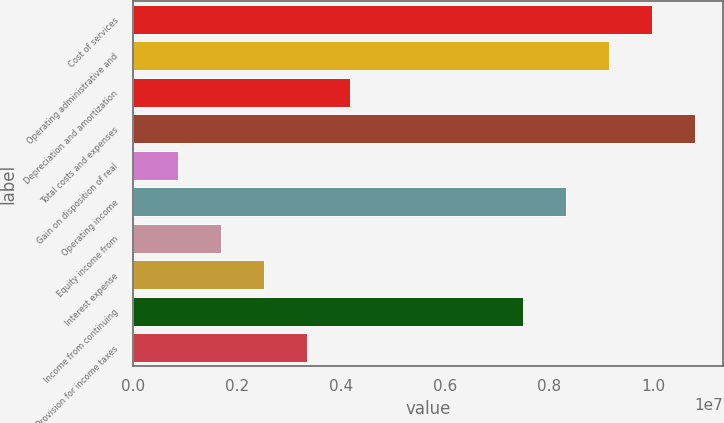Convert chart. <chart><loc_0><loc_0><loc_500><loc_500><bar_chart><fcel>Cost of services<fcel>Operating administrative and<fcel>Depreciation and amortization<fcel>Total costs and expenses<fcel>Gain on disposition of real<fcel>Operating income<fcel>Equity income from<fcel>Interest expense<fcel>Income from continuing<fcel>Provision for income taxes<nl><fcel>9.97259e+06<fcel>9.14396e+06<fcel>4.17216e+06<fcel>1.08012e+07<fcel>857632<fcel>8.31532e+06<fcel>1.68626e+06<fcel>2.5149e+06<fcel>7.48669e+06<fcel>3.34353e+06<nl></chart> 